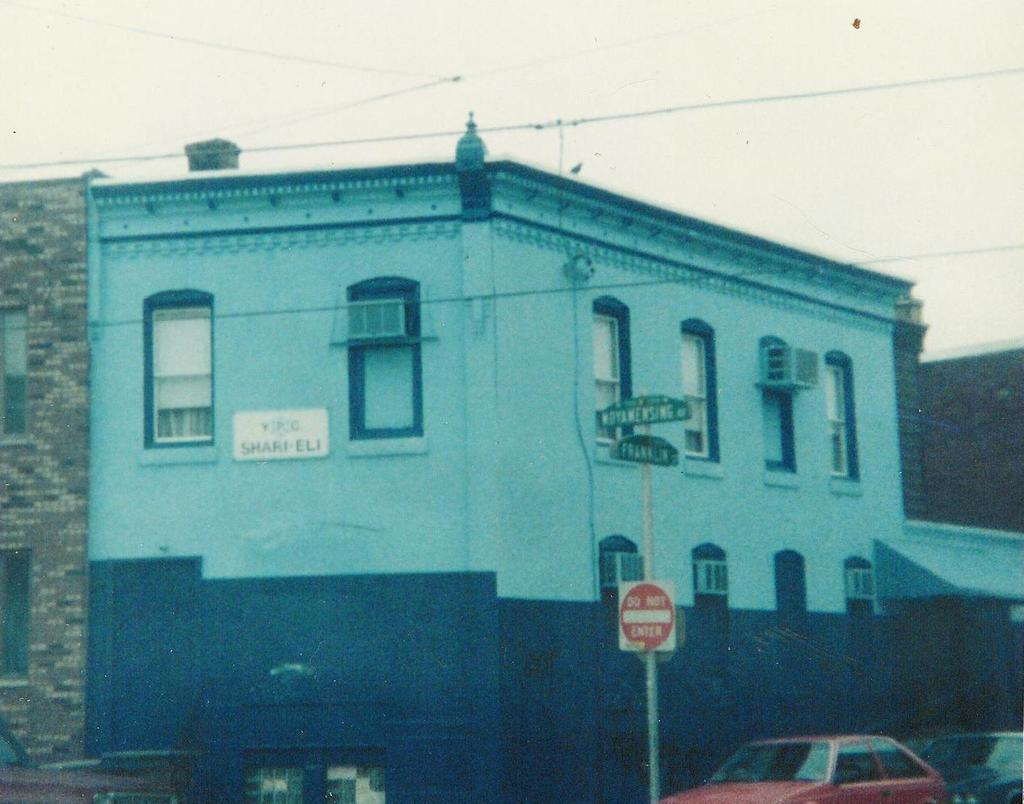What type of structure is in the image? There is a building in the image. What feature of the building can be seen? The building has windows. What devices are visible in the image? Air conditioners are visible in the image. What type of urban infrastructure is present in the image? Street poles are present in the image. What type of signage is in the image? Information boards are in the image. What type of electrical infrastructure is visible in the image? Electric cables are visible in the image. What type of transportation is in the image? Motor vehicles are in the image. What part of the natural environment is visible in the image? The sky is visible in the image. What type of farm animals can be seen grazing in the image? There is no farm or farm animals present in the image. 